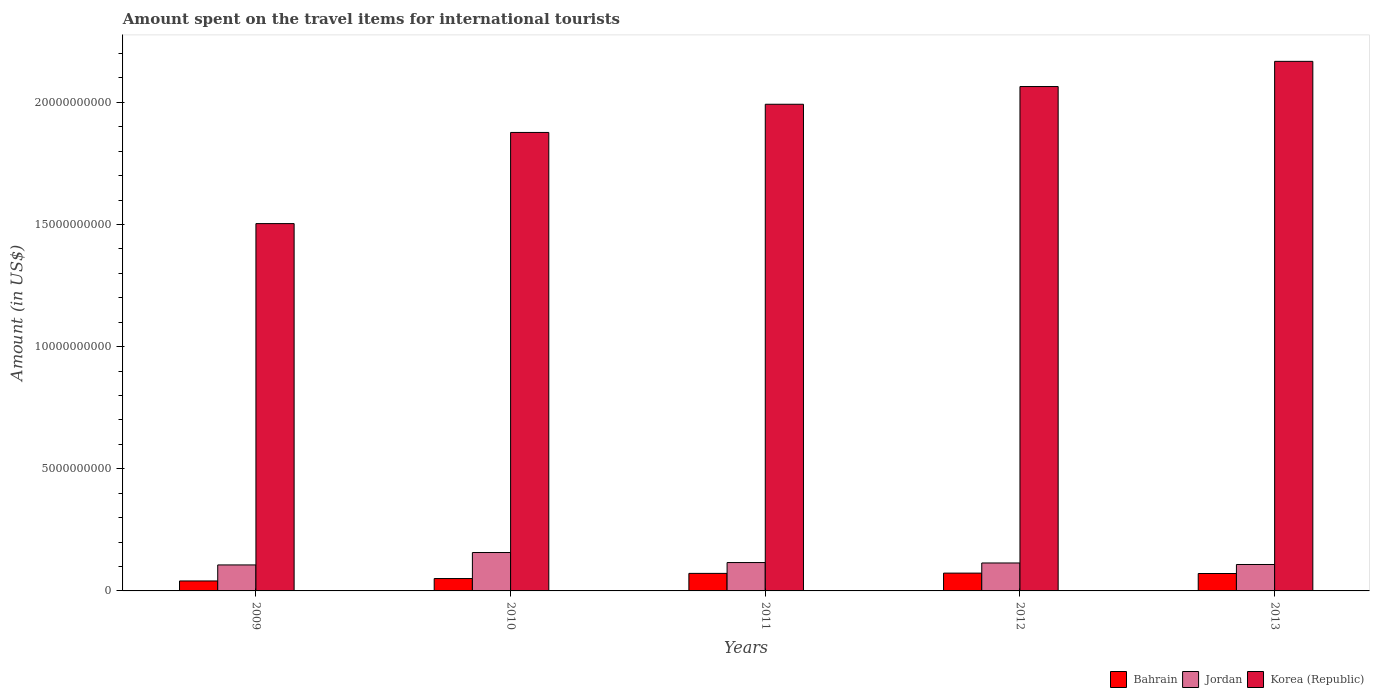How many different coloured bars are there?
Provide a short and direct response. 3. Are the number of bars on each tick of the X-axis equal?
Your answer should be compact. Yes. In how many cases, is the number of bars for a given year not equal to the number of legend labels?
Provide a short and direct response. 0. What is the amount spent on the travel items for international tourists in Bahrain in 2011?
Your answer should be very brief. 7.18e+08. Across all years, what is the maximum amount spent on the travel items for international tourists in Jordan?
Your answer should be very brief. 1.57e+09. Across all years, what is the minimum amount spent on the travel items for international tourists in Jordan?
Your answer should be very brief. 1.06e+09. In which year was the amount spent on the travel items for international tourists in Bahrain minimum?
Ensure brevity in your answer.  2009. What is the total amount spent on the travel items for international tourists in Jordan in the graph?
Provide a short and direct response. 6.02e+09. What is the difference between the amount spent on the travel items for international tourists in Jordan in 2010 and that in 2011?
Your response must be concise. 4.11e+08. What is the difference between the amount spent on the travel items for international tourists in Korea (Republic) in 2010 and the amount spent on the travel items for international tourists in Bahrain in 2013?
Your answer should be compact. 1.81e+1. What is the average amount spent on the travel items for international tourists in Jordan per year?
Make the answer very short. 1.20e+09. In the year 2011, what is the difference between the amount spent on the travel items for international tourists in Korea (Republic) and amount spent on the travel items for international tourists in Jordan?
Provide a short and direct response. 1.88e+1. What is the ratio of the amount spent on the travel items for international tourists in Bahrain in 2011 to that in 2013?
Your answer should be very brief. 1.01. What is the difference between the highest and the second highest amount spent on the travel items for international tourists in Jordan?
Your answer should be compact. 4.11e+08. What is the difference between the highest and the lowest amount spent on the travel items for international tourists in Jordan?
Provide a short and direct response. 5.08e+08. In how many years, is the amount spent on the travel items for international tourists in Bahrain greater than the average amount spent on the travel items for international tourists in Bahrain taken over all years?
Provide a short and direct response. 3. What does the 1st bar from the right in 2013 represents?
Offer a terse response. Korea (Republic). Is it the case that in every year, the sum of the amount spent on the travel items for international tourists in Bahrain and amount spent on the travel items for international tourists in Korea (Republic) is greater than the amount spent on the travel items for international tourists in Jordan?
Your answer should be compact. Yes. How many bars are there?
Your answer should be compact. 15. Are all the bars in the graph horizontal?
Give a very brief answer. No. What is the difference between two consecutive major ticks on the Y-axis?
Your answer should be compact. 5.00e+09. Are the values on the major ticks of Y-axis written in scientific E-notation?
Give a very brief answer. No. Where does the legend appear in the graph?
Your answer should be compact. Bottom right. What is the title of the graph?
Give a very brief answer. Amount spent on the travel items for international tourists. Does "Suriname" appear as one of the legend labels in the graph?
Offer a very short reply. No. What is the label or title of the X-axis?
Your response must be concise. Years. What is the Amount (in US$) in Bahrain in 2009?
Offer a terse response. 4.08e+08. What is the Amount (in US$) in Jordan in 2009?
Keep it short and to the point. 1.06e+09. What is the Amount (in US$) in Korea (Republic) in 2009?
Provide a succinct answer. 1.50e+1. What is the Amount (in US$) in Bahrain in 2010?
Offer a very short reply. 5.06e+08. What is the Amount (in US$) of Jordan in 2010?
Provide a succinct answer. 1.57e+09. What is the Amount (in US$) in Korea (Republic) in 2010?
Offer a terse response. 1.88e+1. What is the Amount (in US$) in Bahrain in 2011?
Your answer should be compact. 7.18e+08. What is the Amount (in US$) of Jordan in 2011?
Give a very brief answer. 1.16e+09. What is the Amount (in US$) in Korea (Republic) in 2011?
Offer a very short reply. 1.99e+1. What is the Amount (in US$) of Bahrain in 2012?
Provide a succinct answer. 7.29e+08. What is the Amount (in US$) of Jordan in 2012?
Ensure brevity in your answer.  1.14e+09. What is the Amount (in US$) in Korea (Republic) in 2012?
Your answer should be very brief. 2.06e+1. What is the Amount (in US$) of Bahrain in 2013?
Offer a terse response. 7.13e+08. What is the Amount (in US$) of Jordan in 2013?
Make the answer very short. 1.08e+09. What is the Amount (in US$) of Korea (Republic) in 2013?
Provide a succinct answer. 2.17e+1. Across all years, what is the maximum Amount (in US$) of Bahrain?
Your answer should be very brief. 7.29e+08. Across all years, what is the maximum Amount (in US$) of Jordan?
Your response must be concise. 1.57e+09. Across all years, what is the maximum Amount (in US$) of Korea (Republic)?
Give a very brief answer. 2.17e+1. Across all years, what is the minimum Amount (in US$) of Bahrain?
Your answer should be compact. 4.08e+08. Across all years, what is the minimum Amount (in US$) in Jordan?
Make the answer very short. 1.06e+09. Across all years, what is the minimum Amount (in US$) of Korea (Republic)?
Offer a terse response. 1.50e+1. What is the total Amount (in US$) of Bahrain in the graph?
Offer a terse response. 3.07e+09. What is the total Amount (in US$) in Jordan in the graph?
Ensure brevity in your answer.  6.02e+09. What is the total Amount (in US$) in Korea (Republic) in the graph?
Ensure brevity in your answer.  9.60e+1. What is the difference between the Amount (in US$) of Bahrain in 2009 and that in 2010?
Your answer should be very brief. -9.80e+07. What is the difference between the Amount (in US$) in Jordan in 2009 and that in 2010?
Ensure brevity in your answer.  -5.08e+08. What is the difference between the Amount (in US$) in Korea (Republic) in 2009 and that in 2010?
Make the answer very short. -3.73e+09. What is the difference between the Amount (in US$) in Bahrain in 2009 and that in 2011?
Your answer should be compact. -3.10e+08. What is the difference between the Amount (in US$) of Jordan in 2009 and that in 2011?
Ensure brevity in your answer.  -9.70e+07. What is the difference between the Amount (in US$) of Korea (Republic) in 2009 and that in 2011?
Give a very brief answer. -4.88e+09. What is the difference between the Amount (in US$) of Bahrain in 2009 and that in 2012?
Your response must be concise. -3.21e+08. What is the difference between the Amount (in US$) of Jordan in 2009 and that in 2012?
Give a very brief answer. -8.00e+07. What is the difference between the Amount (in US$) in Korea (Republic) in 2009 and that in 2012?
Your answer should be very brief. -5.61e+09. What is the difference between the Amount (in US$) in Bahrain in 2009 and that in 2013?
Your answer should be very brief. -3.05e+08. What is the difference between the Amount (in US$) in Jordan in 2009 and that in 2013?
Keep it short and to the point. -1.80e+07. What is the difference between the Amount (in US$) in Korea (Republic) in 2009 and that in 2013?
Provide a succinct answer. -6.64e+09. What is the difference between the Amount (in US$) of Bahrain in 2010 and that in 2011?
Offer a terse response. -2.12e+08. What is the difference between the Amount (in US$) of Jordan in 2010 and that in 2011?
Your answer should be compact. 4.11e+08. What is the difference between the Amount (in US$) in Korea (Republic) in 2010 and that in 2011?
Provide a short and direct response. -1.15e+09. What is the difference between the Amount (in US$) in Bahrain in 2010 and that in 2012?
Provide a succinct answer. -2.23e+08. What is the difference between the Amount (in US$) of Jordan in 2010 and that in 2012?
Provide a short and direct response. 4.28e+08. What is the difference between the Amount (in US$) of Korea (Republic) in 2010 and that in 2012?
Provide a short and direct response. -1.88e+09. What is the difference between the Amount (in US$) in Bahrain in 2010 and that in 2013?
Offer a terse response. -2.07e+08. What is the difference between the Amount (in US$) of Jordan in 2010 and that in 2013?
Your answer should be very brief. 4.90e+08. What is the difference between the Amount (in US$) in Korea (Republic) in 2010 and that in 2013?
Ensure brevity in your answer.  -2.91e+09. What is the difference between the Amount (in US$) of Bahrain in 2011 and that in 2012?
Your answer should be compact. -1.10e+07. What is the difference between the Amount (in US$) of Jordan in 2011 and that in 2012?
Ensure brevity in your answer.  1.70e+07. What is the difference between the Amount (in US$) in Korea (Republic) in 2011 and that in 2012?
Provide a succinct answer. -7.25e+08. What is the difference between the Amount (in US$) of Bahrain in 2011 and that in 2013?
Ensure brevity in your answer.  5.00e+06. What is the difference between the Amount (in US$) in Jordan in 2011 and that in 2013?
Give a very brief answer. 7.90e+07. What is the difference between the Amount (in US$) in Korea (Republic) in 2011 and that in 2013?
Make the answer very short. -1.76e+09. What is the difference between the Amount (in US$) of Bahrain in 2012 and that in 2013?
Your response must be concise. 1.60e+07. What is the difference between the Amount (in US$) in Jordan in 2012 and that in 2013?
Offer a terse response. 6.20e+07. What is the difference between the Amount (in US$) of Korea (Republic) in 2012 and that in 2013?
Offer a very short reply. -1.03e+09. What is the difference between the Amount (in US$) of Bahrain in 2009 and the Amount (in US$) of Jordan in 2010?
Offer a very short reply. -1.16e+09. What is the difference between the Amount (in US$) of Bahrain in 2009 and the Amount (in US$) of Korea (Republic) in 2010?
Give a very brief answer. -1.84e+1. What is the difference between the Amount (in US$) of Jordan in 2009 and the Amount (in US$) of Korea (Republic) in 2010?
Provide a succinct answer. -1.77e+1. What is the difference between the Amount (in US$) of Bahrain in 2009 and the Amount (in US$) of Jordan in 2011?
Offer a terse response. -7.53e+08. What is the difference between the Amount (in US$) of Bahrain in 2009 and the Amount (in US$) of Korea (Republic) in 2011?
Give a very brief answer. -1.95e+1. What is the difference between the Amount (in US$) of Jordan in 2009 and the Amount (in US$) of Korea (Republic) in 2011?
Your response must be concise. -1.89e+1. What is the difference between the Amount (in US$) in Bahrain in 2009 and the Amount (in US$) in Jordan in 2012?
Your answer should be compact. -7.36e+08. What is the difference between the Amount (in US$) of Bahrain in 2009 and the Amount (in US$) of Korea (Republic) in 2012?
Provide a short and direct response. -2.02e+1. What is the difference between the Amount (in US$) of Jordan in 2009 and the Amount (in US$) of Korea (Republic) in 2012?
Provide a succinct answer. -1.96e+1. What is the difference between the Amount (in US$) of Bahrain in 2009 and the Amount (in US$) of Jordan in 2013?
Make the answer very short. -6.74e+08. What is the difference between the Amount (in US$) of Bahrain in 2009 and the Amount (in US$) of Korea (Republic) in 2013?
Provide a succinct answer. -2.13e+1. What is the difference between the Amount (in US$) in Jordan in 2009 and the Amount (in US$) in Korea (Republic) in 2013?
Provide a succinct answer. -2.06e+1. What is the difference between the Amount (in US$) of Bahrain in 2010 and the Amount (in US$) of Jordan in 2011?
Make the answer very short. -6.55e+08. What is the difference between the Amount (in US$) in Bahrain in 2010 and the Amount (in US$) in Korea (Republic) in 2011?
Offer a very short reply. -1.94e+1. What is the difference between the Amount (in US$) in Jordan in 2010 and the Amount (in US$) in Korea (Republic) in 2011?
Ensure brevity in your answer.  -1.83e+1. What is the difference between the Amount (in US$) of Bahrain in 2010 and the Amount (in US$) of Jordan in 2012?
Give a very brief answer. -6.38e+08. What is the difference between the Amount (in US$) in Bahrain in 2010 and the Amount (in US$) in Korea (Republic) in 2012?
Keep it short and to the point. -2.01e+1. What is the difference between the Amount (in US$) of Jordan in 2010 and the Amount (in US$) of Korea (Republic) in 2012?
Your response must be concise. -1.91e+1. What is the difference between the Amount (in US$) in Bahrain in 2010 and the Amount (in US$) in Jordan in 2013?
Provide a succinct answer. -5.76e+08. What is the difference between the Amount (in US$) of Bahrain in 2010 and the Amount (in US$) of Korea (Republic) in 2013?
Your answer should be very brief. -2.12e+1. What is the difference between the Amount (in US$) of Jordan in 2010 and the Amount (in US$) of Korea (Republic) in 2013?
Provide a succinct answer. -2.01e+1. What is the difference between the Amount (in US$) of Bahrain in 2011 and the Amount (in US$) of Jordan in 2012?
Your answer should be compact. -4.26e+08. What is the difference between the Amount (in US$) in Bahrain in 2011 and the Amount (in US$) in Korea (Republic) in 2012?
Your answer should be very brief. -1.99e+1. What is the difference between the Amount (in US$) in Jordan in 2011 and the Amount (in US$) in Korea (Republic) in 2012?
Give a very brief answer. -1.95e+1. What is the difference between the Amount (in US$) in Bahrain in 2011 and the Amount (in US$) in Jordan in 2013?
Give a very brief answer. -3.64e+08. What is the difference between the Amount (in US$) in Bahrain in 2011 and the Amount (in US$) in Korea (Republic) in 2013?
Make the answer very short. -2.10e+1. What is the difference between the Amount (in US$) of Jordan in 2011 and the Amount (in US$) of Korea (Republic) in 2013?
Offer a terse response. -2.05e+1. What is the difference between the Amount (in US$) of Bahrain in 2012 and the Amount (in US$) of Jordan in 2013?
Provide a short and direct response. -3.53e+08. What is the difference between the Amount (in US$) of Bahrain in 2012 and the Amount (in US$) of Korea (Republic) in 2013?
Your response must be concise. -2.09e+1. What is the difference between the Amount (in US$) in Jordan in 2012 and the Amount (in US$) in Korea (Republic) in 2013?
Give a very brief answer. -2.05e+1. What is the average Amount (in US$) of Bahrain per year?
Offer a very short reply. 6.15e+08. What is the average Amount (in US$) in Jordan per year?
Ensure brevity in your answer.  1.20e+09. What is the average Amount (in US$) of Korea (Republic) per year?
Your response must be concise. 1.92e+1. In the year 2009, what is the difference between the Amount (in US$) in Bahrain and Amount (in US$) in Jordan?
Ensure brevity in your answer.  -6.56e+08. In the year 2009, what is the difference between the Amount (in US$) in Bahrain and Amount (in US$) in Korea (Republic)?
Keep it short and to the point. -1.46e+1. In the year 2009, what is the difference between the Amount (in US$) of Jordan and Amount (in US$) of Korea (Republic)?
Your response must be concise. -1.40e+1. In the year 2010, what is the difference between the Amount (in US$) of Bahrain and Amount (in US$) of Jordan?
Give a very brief answer. -1.07e+09. In the year 2010, what is the difference between the Amount (in US$) of Bahrain and Amount (in US$) of Korea (Republic)?
Give a very brief answer. -1.83e+1. In the year 2010, what is the difference between the Amount (in US$) in Jordan and Amount (in US$) in Korea (Republic)?
Offer a very short reply. -1.72e+1. In the year 2011, what is the difference between the Amount (in US$) of Bahrain and Amount (in US$) of Jordan?
Your answer should be very brief. -4.43e+08. In the year 2011, what is the difference between the Amount (in US$) of Bahrain and Amount (in US$) of Korea (Republic)?
Keep it short and to the point. -1.92e+1. In the year 2011, what is the difference between the Amount (in US$) in Jordan and Amount (in US$) in Korea (Republic)?
Provide a succinct answer. -1.88e+1. In the year 2012, what is the difference between the Amount (in US$) of Bahrain and Amount (in US$) of Jordan?
Give a very brief answer. -4.15e+08. In the year 2012, what is the difference between the Amount (in US$) of Bahrain and Amount (in US$) of Korea (Republic)?
Make the answer very short. -1.99e+1. In the year 2012, what is the difference between the Amount (in US$) in Jordan and Amount (in US$) in Korea (Republic)?
Your answer should be compact. -1.95e+1. In the year 2013, what is the difference between the Amount (in US$) of Bahrain and Amount (in US$) of Jordan?
Your answer should be compact. -3.69e+08. In the year 2013, what is the difference between the Amount (in US$) in Bahrain and Amount (in US$) in Korea (Republic)?
Offer a terse response. -2.10e+1. In the year 2013, what is the difference between the Amount (in US$) of Jordan and Amount (in US$) of Korea (Republic)?
Keep it short and to the point. -2.06e+1. What is the ratio of the Amount (in US$) in Bahrain in 2009 to that in 2010?
Give a very brief answer. 0.81. What is the ratio of the Amount (in US$) of Jordan in 2009 to that in 2010?
Keep it short and to the point. 0.68. What is the ratio of the Amount (in US$) in Korea (Republic) in 2009 to that in 2010?
Offer a very short reply. 0.8. What is the ratio of the Amount (in US$) in Bahrain in 2009 to that in 2011?
Your answer should be compact. 0.57. What is the ratio of the Amount (in US$) in Jordan in 2009 to that in 2011?
Provide a short and direct response. 0.92. What is the ratio of the Amount (in US$) in Korea (Republic) in 2009 to that in 2011?
Your answer should be very brief. 0.75. What is the ratio of the Amount (in US$) of Bahrain in 2009 to that in 2012?
Offer a very short reply. 0.56. What is the ratio of the Amount (in US$) of Jordan in 2009 to that in 2012?
Provide a succinct answer. 0.93. What is the ratio of the Amount (in US$) in Korea (Republic) in 2009 to that in 2012?
Your answer should be very brief. 0.73. What is the ratio of the Amount (in US$) in Bahrain in 2009 to that in 2013?
Your answer should be compact. 0.57. What is the ratio of the Amount (in US$) in Jordan in 2009 to that in 2013?
Your response must be concise. 0.98. What is the ratio of the Amount (in US$) of Korea (Republic) in 2009 to that in 2013?
Your answer should be compact. 0.69. What is the ratio of the Amount (in US$) in Bahrain in 2010 to that in 2011?
Provide a succinct answer. 0.7. What is the ratio of the Amount (in US$) of Jordan in 2010 to that in 2011?
Ensure brevity in your answer.  1.35. What is the ratio of the Amount (in US$) of Korea (Republic) in 2010 to that in 2011?
Provide a short and direct response. 0.94. What is the ratio of the Amount (in US$) in Bahrain in 2010 to that in 2012?
Provide a short and direct response. 0.69. What is the ratio of the Amount (in US$) in Jordan in 2010 to that in 2012?
Offer a very short reply. 1.37. What is the ratio of the Amount (in US$) in Korea (Republic) in 2010 to that in 2012?
Provide a succinct answer. 0.91. What is the ratio of the Amount (in US$) of Bahrain in 2010 to that in 2013?
Provide a short and direct response. 0.71. What is the ratio of the Amount (in US$) of Jordan in 2010 to that in 2013?
Make the answer very short. 1.45. What is the ratio of the Amount (in US$) in Korea (Republic) in 2010 to that in 2013?
Ensure brevity in your answer.  0.87. What is the ratio of the Amount (in US$) in Bahrain in 2011 to that in 2012?
Offer a very short reply. 0.98. What is the ratio of the Amount (in US$) of Jordan in 2011 to that in 2012?
Keep it short and to the point. 1.01. What is the ratio of the Amount (in US$) in Korea (Republic) in 2011 to that in 2012?
Your answer should be compact. 0.96. What is the ratio of the Amount (in US$) of Bahrain in 2011 to that in 2013?
Offer a terse response. 1.01. What is the ratio of the Amount (in US$) in Jordan in 2011 to that in 2013?
Offer a very short reply. 1.07. What is the ratio of the Amount (in US$) of Korea (Republic) in 2011 to that in 2013?
Give a very brief answer. 0.92. What is the ratio of the Amount (in US$) in Bahrain in 2012 to that in 2013?
Your answer should be very brief. 1.02. What is the ratio of the Amount (in US$) in Jordan in 2012 to that in 2013?
Provide a short and direct response. 1.06. What is the difference between the highest and the second highest Amount (in US$) of Bahrain?
Make the answer very short. 1.10e+07. What is the difference between the highest and the second highest Amount (in US$) of Jordan?
Make the answer very short. 4.11e+08. What is the difference between the highest and the second highest Amount (in US$) of Korea (Republic)?
Offer a terse response. 1.03e+09. What is the difference between the highest and the lowest Amount (in US$) of Bahrain?
Offer a terse response. 3.21e+08. What is the difference between the highest and the lowest Amount (in US$) of Jordan?
Your answer should be very brief. 5.08e+08. What is the difference between the highest and the lowest Amount (in US$) in Korea (Republic)?
Provide a short and direct response. 6.64e+09. 